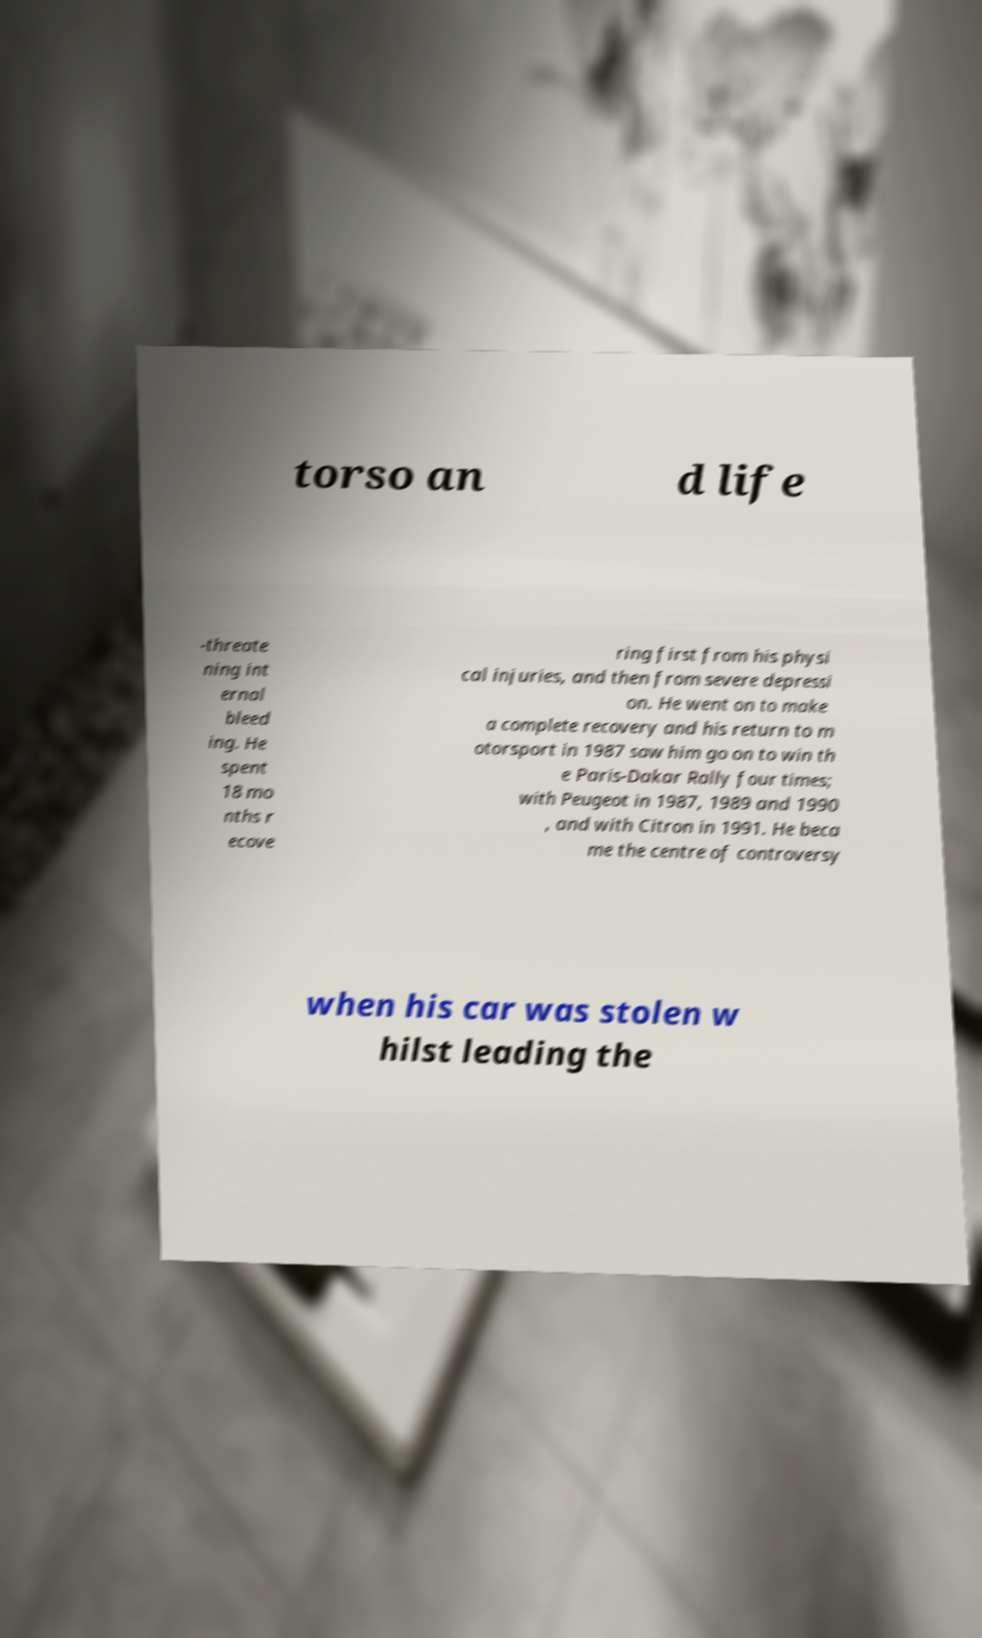Please identify and transcribe the text found in this image. torso an d life -threate ning int ernal bleed ing. He spent 18 mo nths r ecove ring first from his physi cal injuries, and then from severe depressi on. He went on to make a complete recovery and his return to m otorsport in 1987 saw him go on to win th e Paris-Dakar Rally four times; with Peugeot in 1987, 1989 and 1990 , and with Citron in 1991. He beca me the centre of controversy when his car was stolen w hilst leading the 